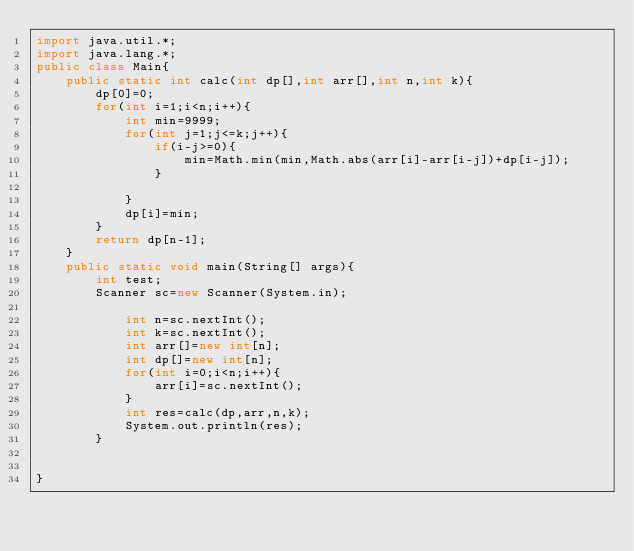<code> <loc_0><loc_0><loc_500><loc_500><_Java_>import java.util.*;
import java.lang.*;
public class Main{
    public static int calc(int dp[],int arr[],int n,int k){
        dp[0]=0;
        for(int i=1;i<n;i++){
            int min=9999;
            for(int j=1;j<=k;j++){
                if(i-j>=0){
                    min=Math.min(min,Math.abs(arr[i]-arr[i-j])+dp[i-j]);
                }
                
            }
            dp[i]=min;
        }
        return dp[n-1];
    }
    public static void main(String[] args){
        int test;
        Scanner sc=new Scanner(System.in);

            int n=sc.nextInt();
            int k=sc.nextInt();
            int arr[]=new int[n];
            int dp[]=new int[n];
            for(int i=0;i<n;i++){
                arr[i]=sc.nextInt();
            }
            int res=calc(dp,arr,n,k);
            System.out.println(res);
        }

    
}</code> 